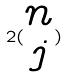Convert formula to latex. <formula><loc_0><loc_0><loc_500><loc_500>2 ( \begin{matrix} n \\ j \end{matrix} )</formula> 